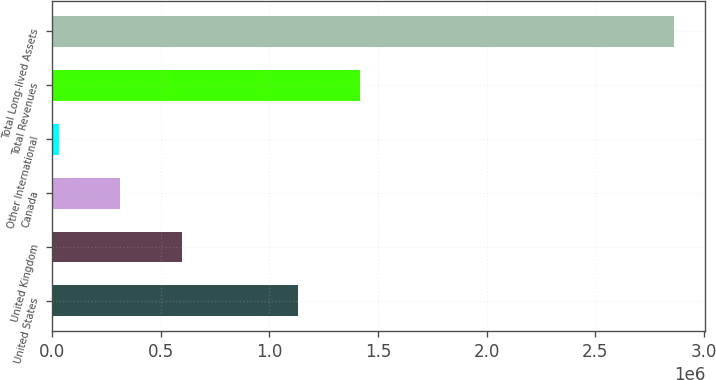Convert chart to OTSL. <chart><loc_0><loc_0><loc_500><loc_500><bar_chart><fcel>United States<fcel>United Kingdom<fcel>Canada<fcel>Other International<fcel>Total Revenues<fcel>Total Long-lived Assets<nl><fcel>1.134e+06<fcel>596845<fcel>313499<fcel>30153<fcel>1.41735e+06<fcel>2.86362e+06<nl></chart> 